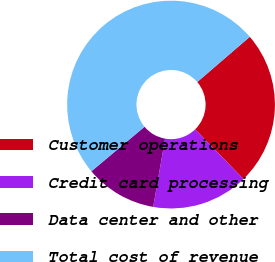Convert chart to OTSL. <chart><loc_0><loc_0><loc_500><loc_500><pie_chart><fcel>Customer operations<fcel>Credit card processing<fcel>Data center and other<fcel>Total cost of revenue<nl><fcel>24.03%<fcel>15.02%<fcel>11.16%<fcel>49.79%<nl></chart> 